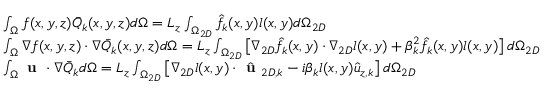Convert formula to latex. <formula><loc_0><loc_0><loc_500><loc_500>\begin{array} { r l } & { \int _ { \Omega } f ( x , y , z ) \bar { Q } _ { k } ( x , y , z ) d \Omega = L _ { z } \int _ { \Omega _ { 2 D } } \hat { f } _ { k } ( x , y ) l ( x , y ) d \Omega _ { 2 D } } \\ & { \int _ { \Omega } \nabla f ( x , y , z ) \cdot \nabla \bar { Q } _ { k } ( x , y , z ) d \Omega = L _ { z } \int _ { \Omega _ { 2 D } } \left [ \nabla _ { 2 D } \hat { f } _ { k } ( x , y ) \cdot \nabla _ { 2 D } l ( x , y ) + \beta _ { k } ^ { 2 } \hat { f } _ { k } ( x , y ) l ( x , y ) \right ] d \Omega _ { 2 D } } \\ & { \int _ { \Omega } u \cdot \nabla \bar { Q } _ { k } d \Omega = L _ { z } \int _ { \Omega _ { 2 D } } \left [ \nabla _ { 2 D } l ( x , y ) \cdot \hat { u } _ { 2 D , k } - i \beta _ { k } l ( x , y ) \hat { u } _ { z , k } \right ] d \Omega _ { 2 D } } \end{array}</formula> 